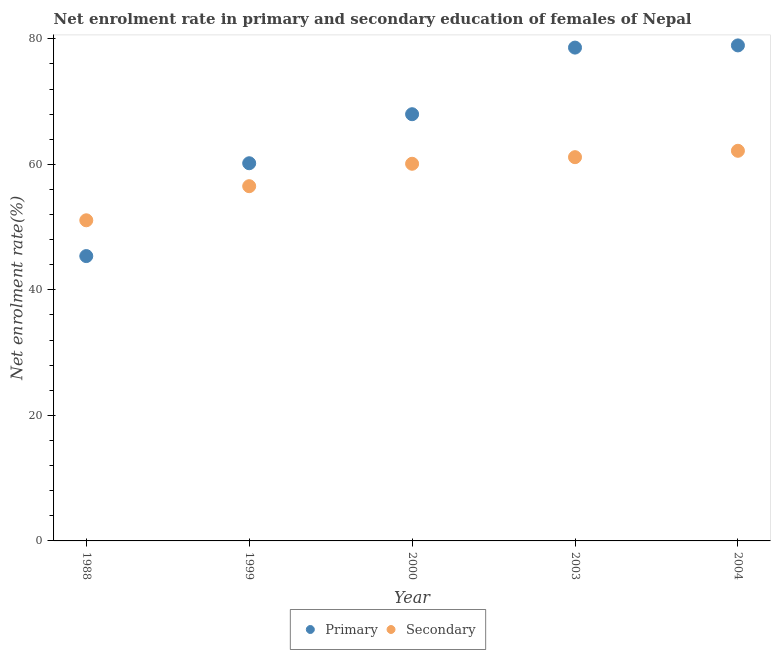Is the number of dotlines equal to the number of legend labels?
Your answer should be very brief. Yes. What is the enrollment rate in secondary education in 1999?
Your response must be concise. 56.52. Across all years, what is the maximum enrollment rate in primary education?
Your response must be concise. 78.96. Across all years, what is the minimum enrollment rate in primary education?
Ensure brevity in your answer.  45.39. In which year was the enrollment rate in secondary education maximum?
Make the answer very short. 2004. What is the total enrollment rate in primary education in the graph?
Give a very brief answer. 331.12. What is the difference between the enrollment rate in primary education in 2000 and that in 2003?
Keep it short and to the point. -10.61. What is the difference between the enrollment rate in secondary education in 2003 and the enrollment rate in primary education in 2000?
Make the answer very short. -6.85. What is the average enrollment rate in primary education per year?
Provide a succinct answer. 66.22. In the year 2000, what is the difference between the enrollment rate in secondary education and enrollment rate in primary education?
Offer a very short reply. -7.9. In how many years, is the enrollment rate in primary education greater than 60 %?
Provide a short and direct response. 4. What is the ratio of the enrollment rate in secondary education in 2003 to that in 2004?
Provide a succinct answer. 0.98. Is the enrollment rate in primary education in 2000 less than that in 2003?
Provide a short and direct response. Yes. What is the difference between the highest and the second highest enrollment rate in primary education?
Make the answer very short. 0.35. What is the difference between the highest and the lowest enrollment rate in primary education?
Your answer should be very brief. 33.57. Is the enrollment rate in secondary education strictly greater than the enrollment rate in primary education over the years?
Provide a short and direct response. No. What is the difference between two consecutive major ticks on the Y-axis?
Provide a succinct answer. 20. Are the values on the major ticks of Y-axis written in scientific E-notation?
Give a very brief answer. No. Does the graph contain any zero values?
Give a very brief answer. No. Does the graph contain grids?
Your answer should be very brief. No. Where does the legend appear in the graph?
Your answer should be compact. Bottom center. How are the legend labels stacked?
Ensure brevity in your answer.  Horizontal. What is the title of the graph?
Keep it short and to the point. Net enrolment rate in primary and secondary education of females of Nepal. Does "Public funds" appear as one of the legend labels in the graph?
Offer a very short reply. No. What is the label or title of the Y-axis?
Ensure brevity in your answer.  Net enrolment rate(%). What is the Net enrolment rate(%) in Primary in 1988?
Your answer should be compact. 45.39. What is the Net enrolment rate(%) of Secondary in 1988?
Provide a short and direct response. 51.09. What is the Net enrolment rate(%) in Primary in 1999?
Provide a succinct answer. 60.18. What is the Net enrolment rate(%) in Secondary in 1999?
Ensure brevity in your answer.  56.52. What is the Net enrolment rate(%) of Primary in 2000?
Your answer should be very brief. 67.99. What is the Net enrolment rate(%) of Secondary in 2000?
Your answer should be very brief. 60.1. What is the Net enrolment rate(%) of Primary in 2003?
Your answer should be very brief. 78.61. What is the Net enrolment rate(%) of Secondary in 2003?
Your response must be concise. 61.15. What is the Net enrolment rate(%) in Primary in 2004?
Your answer should be compact. 78.96. What is the Net enrolment rate(%) in Secondary in 2004?
Offer a very short reply. 62.16. Across all years, what is the maximum Net enrolment rate(%) in Primary?
Give a very brief answer. 78.96. Across all years, what is the maximum Net enrolment rate(%) in Secondary?
Make the answer very short. 62.16. Across all years, what is the minimum Net enrolment rate(%) in Primary?
Give a very brief answer. 45.39. Across all years, what is the minimum Net enrolment rate(%) in Secondary?
Offer a terse response. 51.09. What is the total Net enrolment rate(%) in Primary in the graph?
Ensure brevity in your answer.  331.12. What is the total Net enrolment rate(%) of Secondary in the graph?
Give a very brief answer. 291.02. What is the difference between the Net enrolment rate(%) of Primary in 1988 and that in 1999?
Provide a succinct answer. -14.79. What is the difference between the Net enrolment rate(%) in Secondary in 1988 and that in 1999?
Your response must be concise. -5.43. What is the difference between the Net enrolment rate(%) in Primary in 1988 and that in 2000?
Provide a succinct answer. -22.61. What is the difference between the Net enrolment rate(%) in Secondary in 1988 and that in 2000?
Give a very brief answer. -9.01. What is the difference between the Net enrolment rate(%) of Primary in 1988 and that in 2003?
Make the answer very short. -33.22. What is the difference between the Net enrolment rate(%) of Secondary in 1988 and that in 2003?
Ensure brevity in your answer.  -10.06. What is the difference between the Net enrolment rate(%) of Primary in 1988 and that in 2004?
Your response must be concise. -33.57. What is the difference between the Net enrolment rate(%) in Secondary in 1988 and that in 2004?
Keep it short and to the point. -11.07. What is the difference between the Net enrolment rate(%) in Primary in 1999 and that in 2000?
Make the answer very short. -7.81. What is the difference between the Net enrolment rate(%) in Secondary in 1999 and that in 2000?
Your response must be concise. -3.57. What is the difference between the Net enrolment rate(%) of Primary in 1999 and that in 2003?
Offer a terse response. -18.43. What is the difference between the Net enrolment rate(%) of Secondary in 1999 and that in 2003?
Give a very brief answer. -4.62. What is the difference between the Net enrolment rate(%) in Primary in 1999 and that in 2004?
Provide a short and direct response. -18.78. What is the difference between the Net enrolment rate(%) in Secondary in 1999 and that in 2004?
Offer a terse response. -5.64. What is the difference between the Net enrolment rate(%) in Primary in 2000 and that in 2003?
Your answer should be very brief. -10.61. What is the difference between the Net enrolment rate(%) of Secondary in 2000 and that in 2003?
Provide a succinct answer. -1.05. What is the difference between the Net enrolment rate(%) of Primary in 2000 and that in 2004?
Your response must be concise. -10.96. What is the difference between the Net enrolment rate(%) in Secondary in 2000 and that in 2004?
Keep it short and to the point. -2.07. What is the difference between the Net enrolment rate(%) in Primary in 2003 and that in 2004?
Offer a terse response. -0.35. What is the difference between the Net enrolment rate(%) in Secondary in 2003 and that in 2004?
Your answer should be very brief. -1.02. What is the difference between the Net enrolment rate(%) of Primary in 1988 and the Net enrolment rate(%) of Secondary in 1999?
Your answer should be compact. -11.14. What is the difference between the Net enrolment rate(%) of Primary in 1988 and the Net enrolment rate(%) of Secondary in 2000?
Provide a succinct answer. -14.71. What is the difference between the Net enrolment rate(%) in Primary in 1988 and the Net enrolment rate(%) in Secondary in 2003?
Your answer should be compact. -15.76. What is the difference between the Net enrolment rate(%) of Primary in 1988 and the Net enrolment rate(%) of Secondary in 2004?
Give a very brief answer. -16.78. What is the difference between the Net enrolment rate(%) of Primary in 1999 and the Net enrolment rate(%) of Secondary in 2000?
Provide a succinct answer. 0.08. What is the difference between the Net enrolment rate(%) of Primary in 1999 and the Net enrolment rate(%) of Secondary in 2003?
Make the answer very short. -0.97. What is the difference between the Net enrolment rate(%) in Primary in 1999 and the Net enrolment rate(%) in Secondary in 2004?
Ensure brevity in your answer.  -1.98. What is the difference between the Net enrolment rate(%) of Primary in 2000 and the Net enrolment rate(%) of Secondary in 2003?
Provide a succinct answer. 6.85. What is the difference between the Net enrolment rate(%) in Primary in 2000 and the Net enrolment rate(%) in Secondary in 2004?
Keep it short and to the point. 5.83. What is the difference between the Net enrolment rate(%) in Primary in 2003 and the Net enrolment rate(%) in Secondary in 2004?
Keep it short and to the point. 16.44. What is the average Net enrolment rate(%) in Primary per year?
Your response must be concise. 66.22. What is the average Net enrolment rate(%) in Secondary per year?
Ensure brevity in your answer.  58.2. In the year 1988, what is the difference between the Net enrolment rate(%) in Primary and Net enrolment rate(%) in Secondary?
Offer a very short reply. -5.7. In the year 1999, what is the difference between the Net enrolment rate(%) in Primary and Net enrolment rate(%) in Secondary?
Make the answer very short. 3.66. In the year 2000, what is the difference between the Net enrolment rate(%) in Primary and Net enrolment rate(%) in Secondary?
Provide a short and direct response. 7.9. In the year 2003, what is the difference between the Net enrolment rate(%) of Primary and Net enrolment rate(%) of Secondary?
Ensure brevity in your answer.  17.46. In the year 2004, what is the difference between the Net enrolment rate(%) in Primary and Net enrolment rate(%) in Secondary?
Provide a short and direct response. 16.79. What is the ratio of the Net enrolment rate(%) of Primary in 1988 to that in 1999?
Keep it short and to the point. 0.75. What is the ratio of the Net enrolment rate(%) in Secondary in 1988 to that in 1999?
Keep it short and to the point. 0.9. What is the ratio of the Net enrolment rate(%) of Primary in 1988 to that in 2000?
Make the answer very short. 0.67. What is the ratio of the Net enrolment rate(%) in Secondary in 1988 to that in 2000?
Your answer should be compact. 0.85. What is the ratio of the Net enrolment rate(%) in Primary in 1988 to that in 2003?
Make the answer very short. 0.58. What is the ratio of the Net enrolment rate(%) of Secondary in 1988 to that in 2003?
Your answer should be compact. 0.84. What is the ratio of the Net enrolment rate(%) of Primary in 1988 to that in 2004?
Provide a succinct answer. 0.57. What is the ratio of the Net enrolment rate(%) of Secondary in 1988 to that in 2004?
Your answer should be compact. 0.82. What is the ratio of the Net enrolment rate(%) of Primary in 1999 to that in 2000?
Make the answer very short. 0.89. What is the ratio of the Net enrolment rate(%) of Secondary in 1999 to that in 2000?
Provide a succinct answer. 0.94. What is the ratio of the Net enrolment rate(%) in Primary in 1999 to that in 2003?
Offer a very short reply. 0.77. What is the ratio of the Net enrolment rate(%) in Secondary in 1999 to that in 2003?
Provide a short and direct response. 0.92. What is the ratio of the Net enrolment rate(%) in Primary in 1999 to that in 2004?
Provide a succinct answer. 0.76. What is the ratio of the Net enrolment rate(%) in Secondary in 1999 to that in 2004?
Offer a terse response. 0.91. What is the ratio of the Net enrolment rate(%) of Primary in 2000 to that in 2003?
Your answer should be compact. 0.86. What is the ratio of the Net enrolment rate(%) in Secondary in 2000 to that in 2003?
Offer a terse response. 0.98. What is the ratio of the Net enrolment rate(%) of Primary in 2000 to that in 2004?
Offer a terse response. 0.86. What is the ratio of the Net enrolment rate(%) in Secondary in 2000 to that in 2004?
Provide a succinct answer. 0.97. What is the ratio of the Net enrolment rate(%) of Primary in 2003 to that in 2004?
Offer a very short reply. 1. What is the ratio of the Net enrolment rate(%) of Secondary in 2003 to that in 2004?
Your response must be concise. 0.98. What is the difference between the highest and the second highest Net enrolment rate(%) in Primary?
Give a very brief answer. 0.35. What is the difference between the highest and the second highest Net enrolment rate(%) of Secondary?
Provide a succinct answer. 1.02. What is the difference between the highest and the lowest Net enrolment rate(%) in Primary?
Offer a very short reply. 33.57. What is the difference between the highest and the lowest Net enrolment rate(%) of Secondary?
Give a very brief answer. 11.07. 